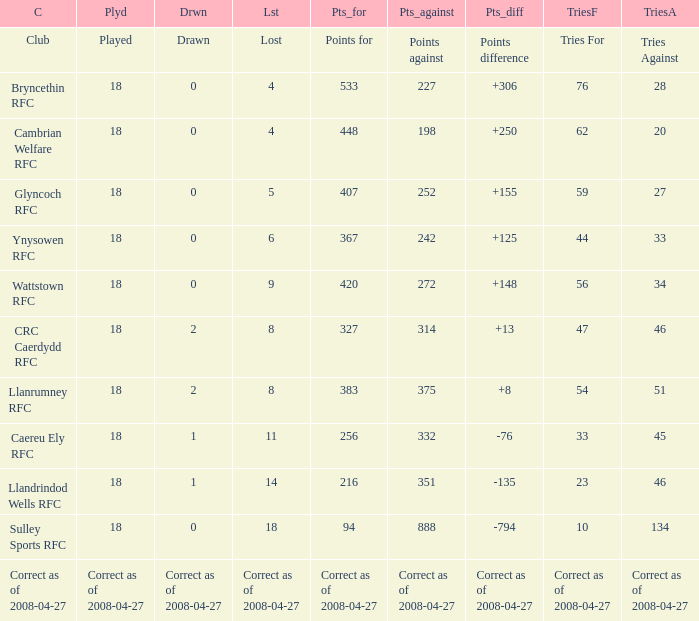What is the value for the item "Tries" when the value of the item "Played" is 18 and the value of the item "Points" is 375? 54.0. Parse the table in full. {'header': ['C', 'Plyd', 'Drwn', 'Lst', 'Pts_for', 'Pts_against', 'Pts_diff', 'TriesF', 'TriesA'], 'rows': [['Club', 'Played', 'Drawn', 'Lost', 'Points for', 'Points against', 'Points difference', 'Tries For', 'Tries Against'], ['Bryncethin RFC', '18', '0', '4', '533', '227', '+306', '76', '28'], ['Cambrian Welfare RFC', '18', '0', '4', '448', '198', '+250', '62', '20'], ['Glyncoch RFC', '18', '0', '5', '407', '252', '+155', '59', '27'], ['Ynysowen RFC', '18', '0', '6', '367', '242', '+125', '44', '33'], ['Wattstown RFC', '18', '0', '9', '420', '272', '+148', '56', '34'], ['CRC Caerdydd RFC', '18', '2', '8', '327', '314', '+13', '47', '46'], ['Llanrumney RFC', '18', '2', '8', '383', '375', '+8', '54', '51'], ['Caereu Ely RFC', '18', '1', '11', '256', '332', '-76', '33', '45'], ['Llandrindod Wells RFC', '18', '1', '14', '216', '351', '-135', '23', '46'], ['Sulley Sports RFC', '18', '0', '18', '94', '888', '-794', '10', '134'], ['Correct as of 2008-04-27', 'Correct as of 2008-04-27', 'Correct as of 2008-04-27', 'Correct as of 2008-04-27', 'Correct as of 2008-04-27', 'Correct as of 2008-04-27', 'Correct as of 2008-04-27', 'Correct as of 2008-04-27', 'Correct as of 2008-04-27']]} 